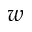Convert formula to latex. <formula><loc_0><loc_0><loc_500><loc_500>w</formula> 